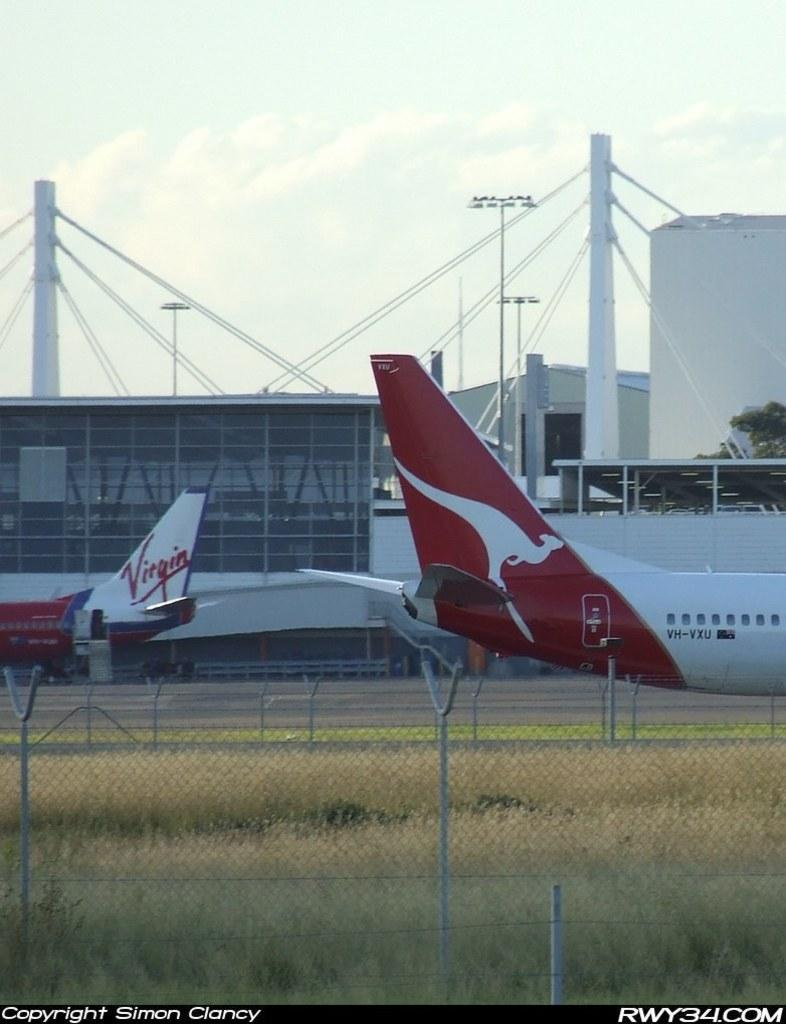<image>
Write a terse but informative summary of the picture. A Virgin airline plane is on the ground near another plane. 